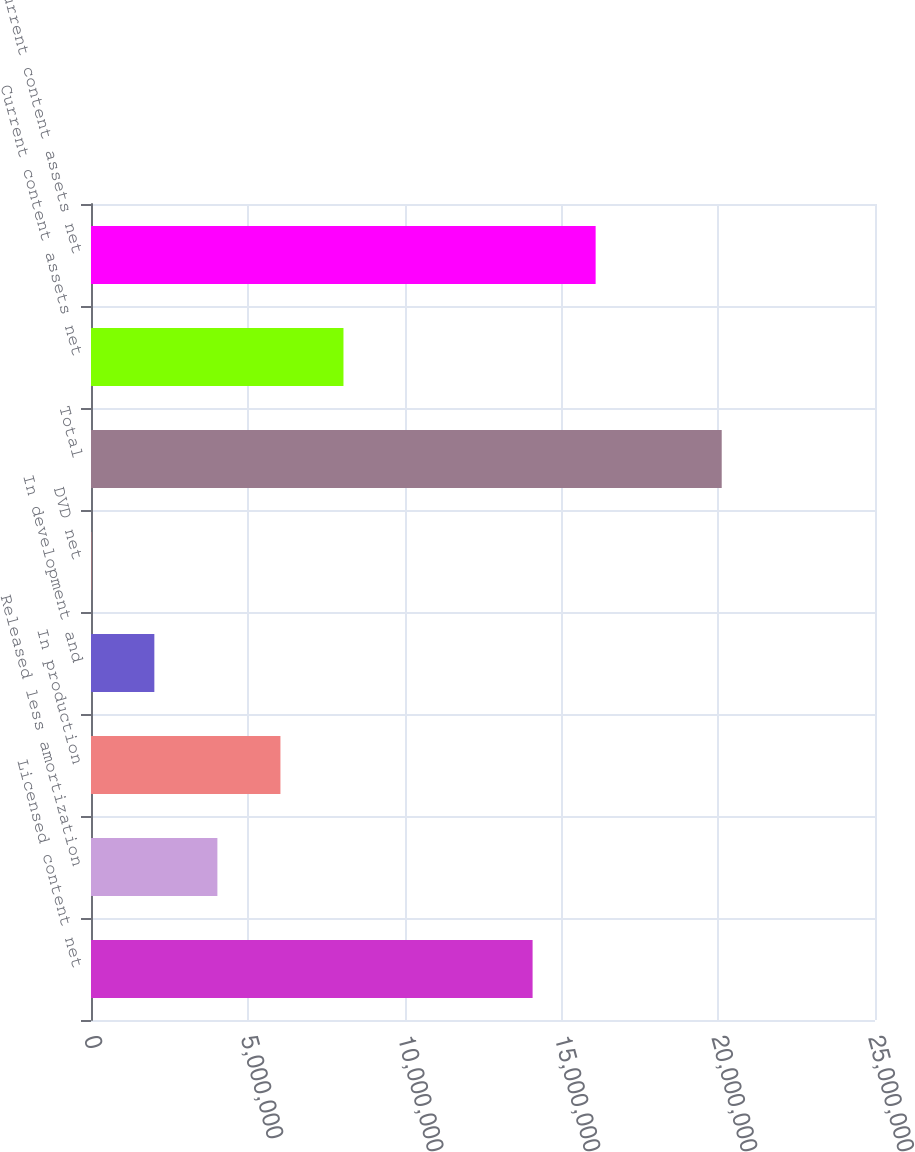Convert chart to OTSL. <chart><loc_0><loc_0><loc_500><loc_500><bar_chart><fcel>Licensed content net<fcel>Released less amortization<fcel>In production<fcel>In development and<fcel>DVD net<fcel>Total<fcel>Current content assets net<fcel>Non-current content assets net<nl><fcel>1.40815e+07<fcel>4.03028e+06<fcel>6.04051e+06<fcel>2.02005e+06<fcel>9813<fcel>2.01121e+07<fcel>8.05074e+06<fcel>1.60917e+07<nl></chart> 